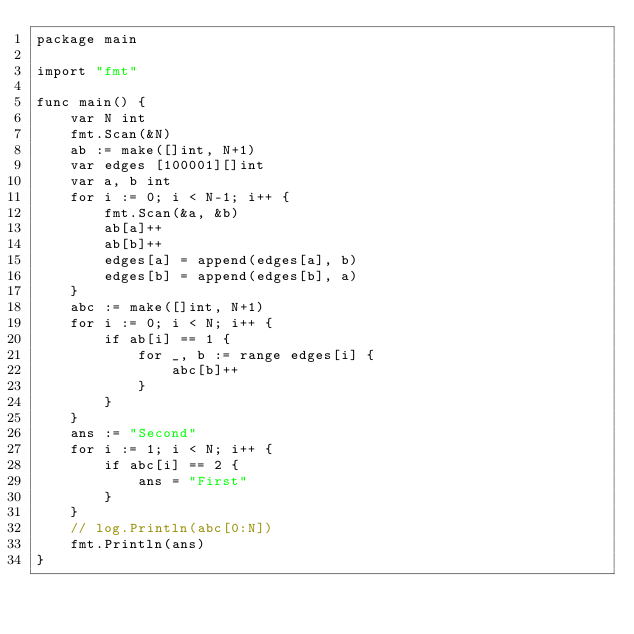<code> <loc_0><loc_0><loc_500><loc_500><_Go_>package main

import "fmt"

func main() {
	var N int
	fmt.Scan(&N)
	ab := make([]int, N+1)
	var edges [100001][]int
	var a, b int
	for i := 0; i < N-1; i++ {
		fmt.Scan(&a, &b)
		ab[a]++
		ab[b]++
		edges[a] = append(edges[a], b)
		edges[b] = append(edges[b], a)
	}
	abc := make([]int, N+1)
	for i := 0; i < N; i++ {
		if ab[i] == 1 {
			for _, b := range edges[i] {
				abc[b]++
			}
		}
	}
	ans := "Second"
	for i := 1; i < N; i++ {
		if abc[i] == 2 {
			ans = "First"
		}
	}
	// log.Println(abc[0:N])
	fmt.Println(ans)
}
</code> 